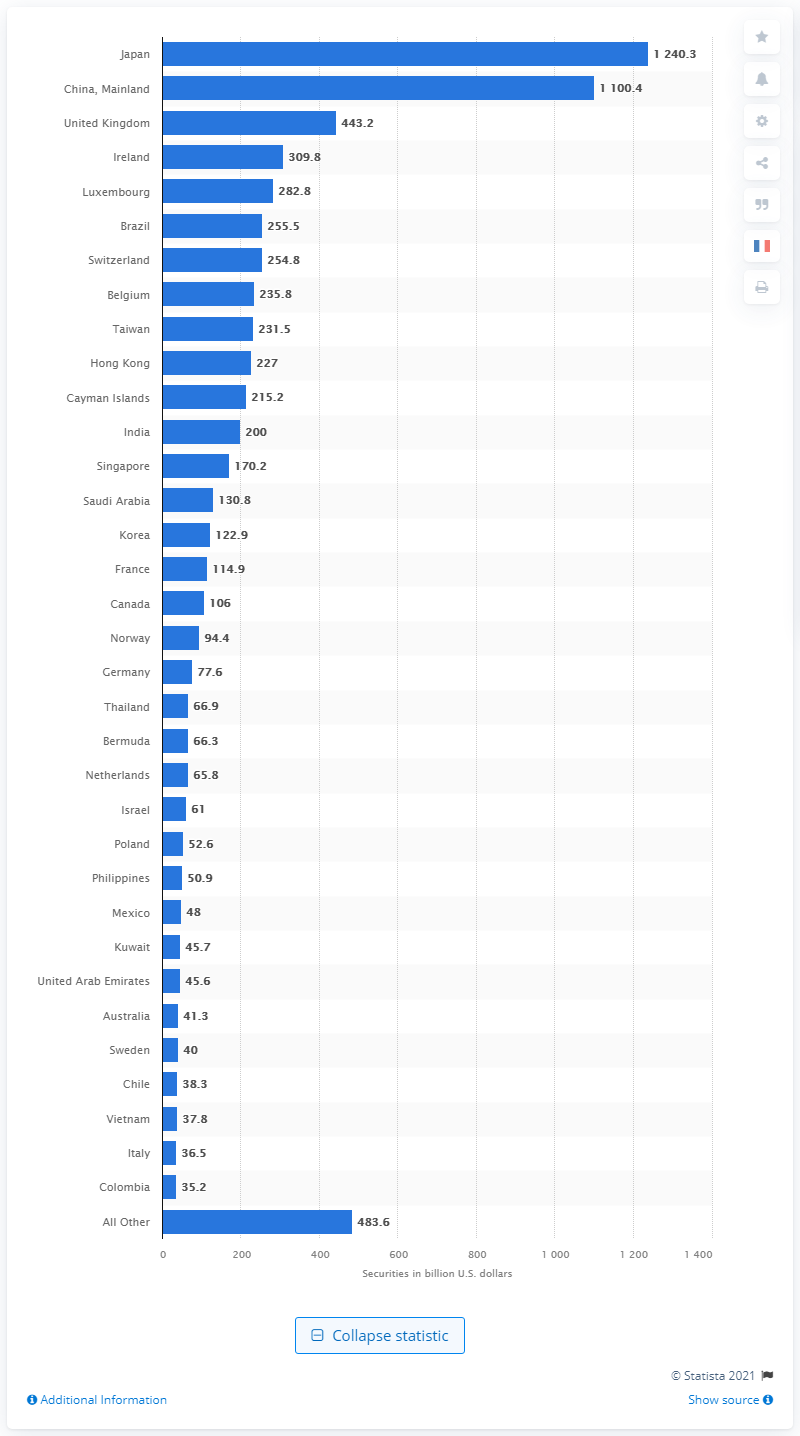Mention a couple of crucial points in this snapshot. As of March 2021, Japan held 1240.3 billion U.S. dollars in treasury securities. 